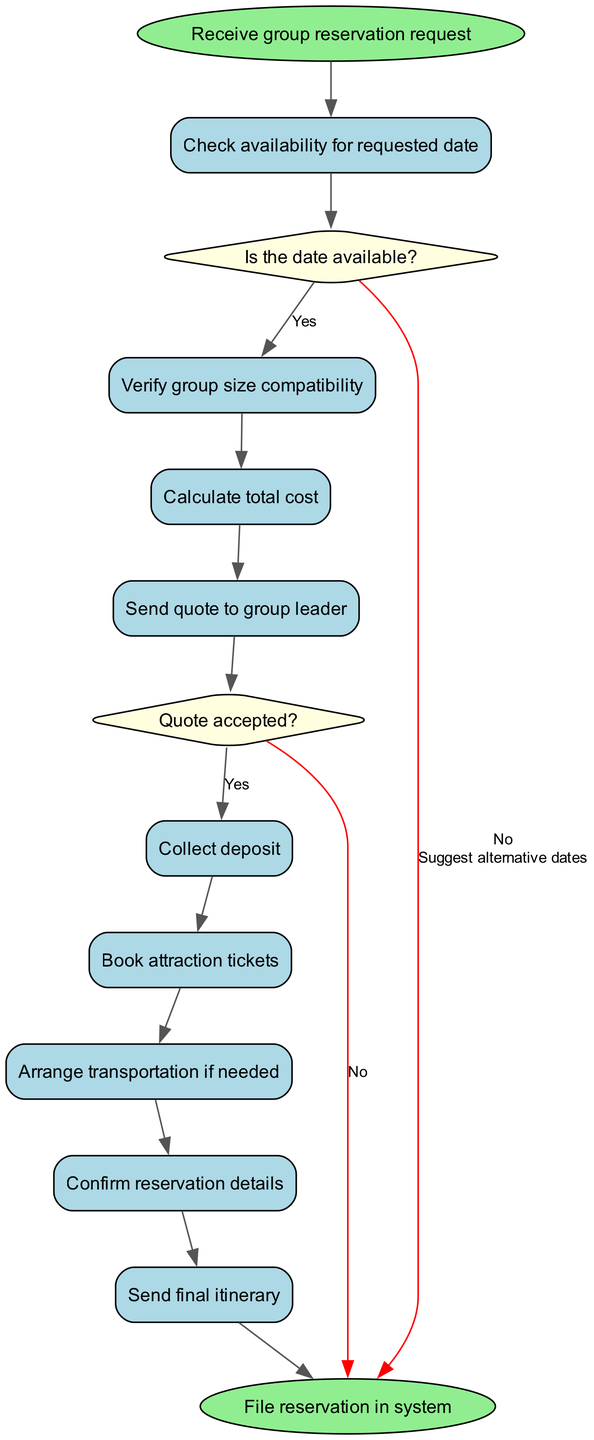What is the first activity in the diagram? The first activity in the diagram is connected directly to the initial node "Receive group reservation request." According to the flow, it leads to the next step.
Answer: Check availability for requested date How many activities are listed in the diagram? The diagram lists a total of eight activities as shown in the activities section.
Answer: Eight What happens if the date is not available? If the date is not available, the flow indicates that the next step is to "Suggest alternative dates." This follows the decision node that checks date availability.
Answer: Suggest alternative dates What is the last activity before the reservation is filed? The last activity before filing the reservation in the system is "Send final itinerary." This is the final step to be executed in the activity flow.
Answer: Send final itinerary What is the outcome if the quote is accepted? If the quote is accepted, the flow proceeds to the next step where the action is to "Collect deposit." This is part of the decision process laid out in the diagram.
Answer: Collect deposit How many decision nodes are present in the diagram? There are two decision nodes present in the diagram, each guiding the flow based on certain questions regarding date availability and quote acceptance.
Answer: Two What activity precedes "Calculate total cost"? "Verify group size compatibility" precedes the "Calculate total cost" activity in the flow of the diagram. This shows the order of steps that must be taken in the process.
Answer: Verify group size compatibility What happens after collecting the deposit? After collecting the deposit, the next activity in the flow is to "Book attraction tickets." This indicates the sequence of actions to be taken once the deposit is secured.
Answer: Book attraction tickets 